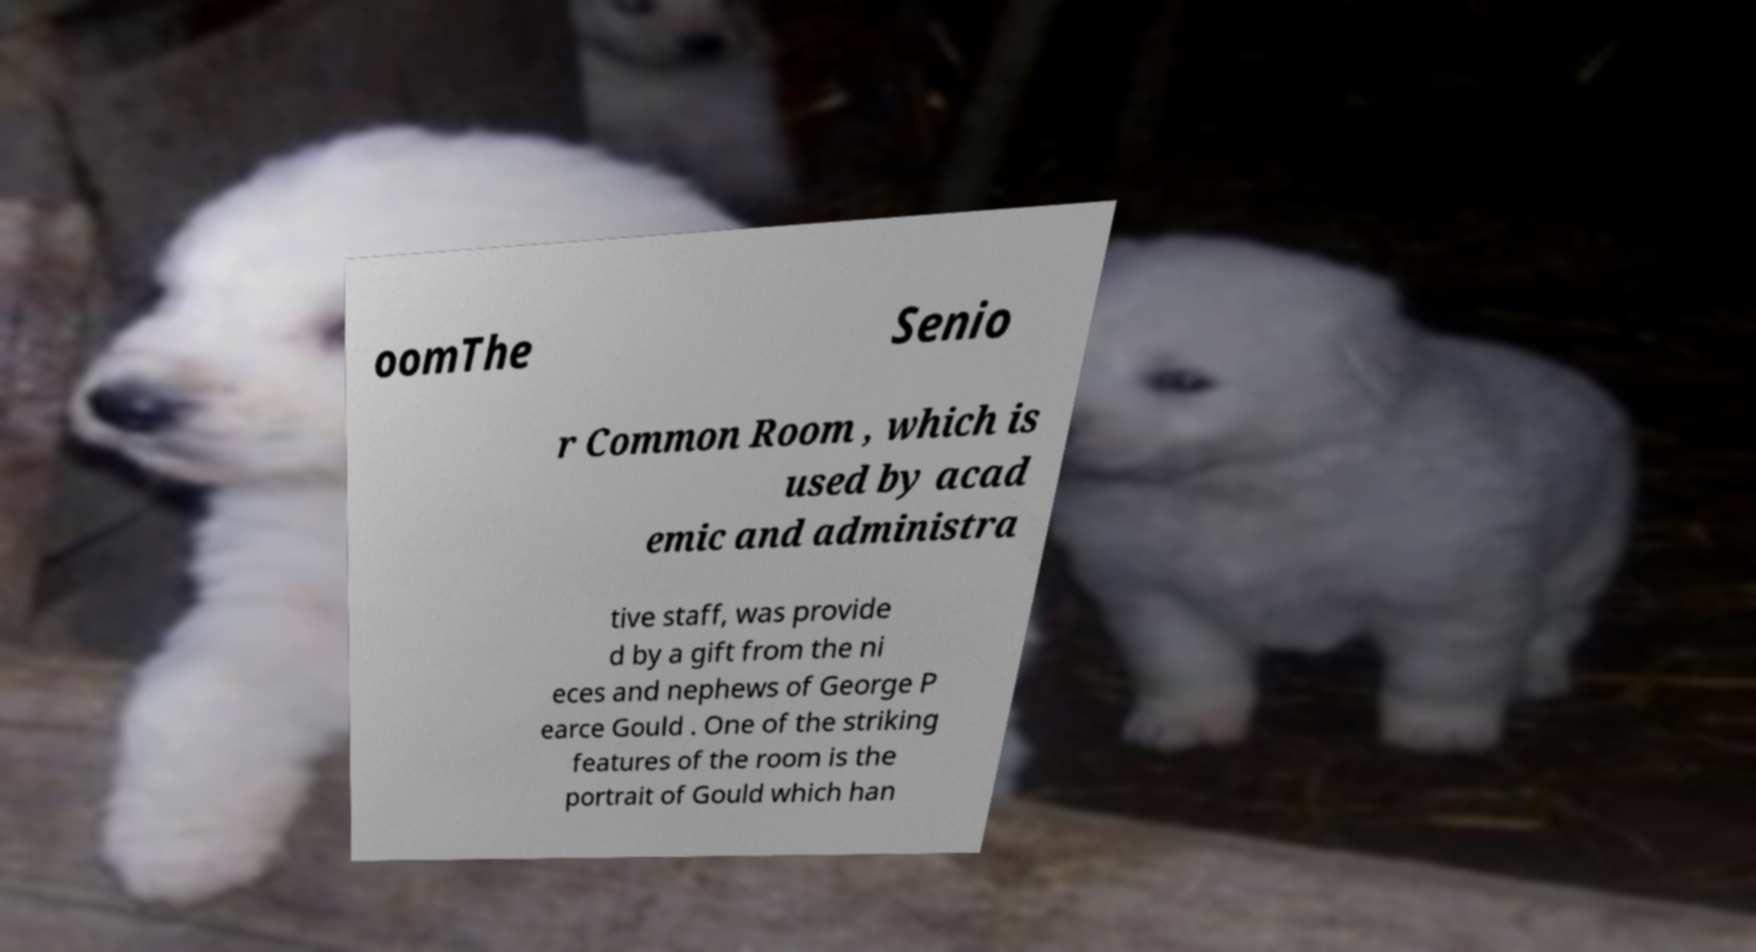Please read and relay the text visible in this image. What does it say? oomThe Senio r Common Room , which is used by acad emic and administra tive staff, was provide d by a gift from the ni eces and nephews of George P earce Gould . One of the striking features of the room is the portrait of Gould which han 